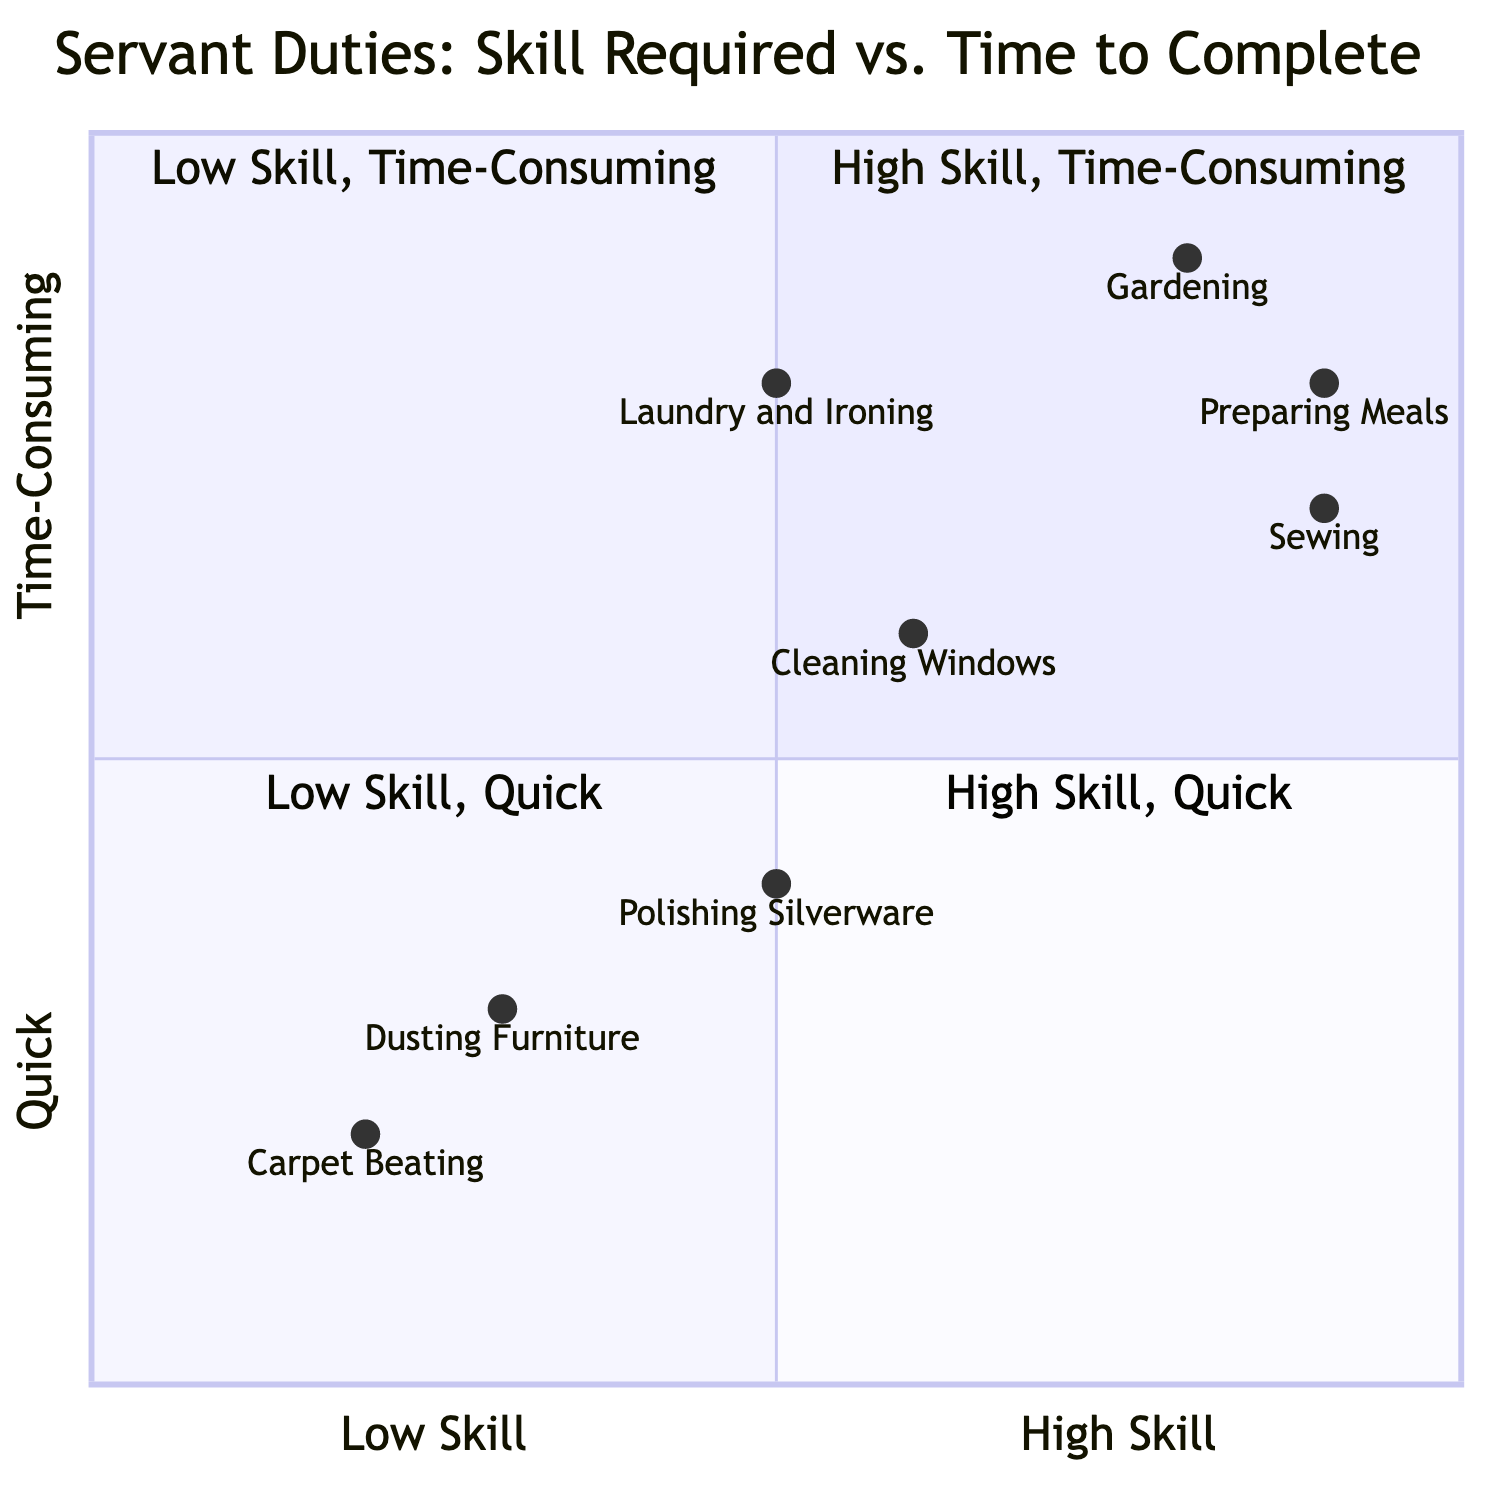What is the task that requires the least skill? By reviewing the skills associated with each task, "Carpet Beating" is identified as requiring "Low" skill.
Answer: Carpet Beating Which task takes the longest time to complete? "Gardening" is the task that takes "Several hours," making it the most time-consuming on the chart.
Answer: Gardening How many tasks require medium skill? There are three tasks that require "Medium" skill: Polishing Silverware, Cleaning Windows, and Laundry and Ironing.
Answer: 3 Which task falls into quadrant 1? In quadrant 1, which represents "High Skill, Time-Consuming," the tasks identified are "Gardening," "Sewing," and "Preparing Meals" based on their plotted positions.
Answer: Gardening, Sewing, Preparing Meals What is the time to complete "Dusting Furniture"? "Dusting Furniture" is labeled as taking "About 45 minutes," based on its specific information in the diagram.
Answer: About 45 minutes Which task has the highest skill required among the quick tasks? Among the tasks that are categorized as "Quick," "Sewing" has the highest skill requirement, as indicated by its position in quadrant 4.
Answer: Sewing How does "Polishing Silverware" compare in time with "Cleaning Windows"? "Polishing Silverware" takes "About 1 hour," while "Cleaning Windows" takes "About 1.5 hours," showing that Cleaning Windows is longer.
Answer: Cleaning Windows is longer What is the skill requirement for "Preparing Meals"? "Preparing Meals" requires "High" skill based on its evaluation in the chart.
Answer: High How many tasks are categorized as quick? There are four tasks categorized as quick, indicated by their positions in quadrant 4 and quadrant 3: Carpet Beating, Dusting Furniture, Polishing Silverware, and Sewing.
Answer: 4 